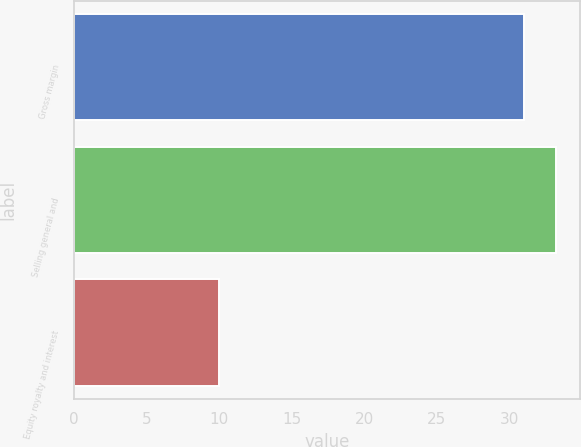<chart> <loc_0><loc_0><loc_500><loc_500><bar_chart><fcel>Gross margin<fcel>Selling general and<fcel>Equity royalty and interest<nl><fcel>31<fcel>33.2<fcel>10<nl></chart> 